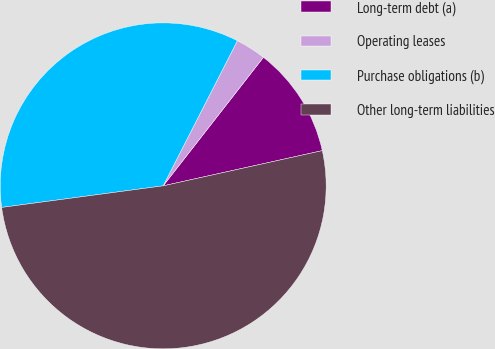Convert chart to OTSL. <chart><loc_0><loc_0><loc_500><loc_500><pie_chart><fcel>Long-term debt (a)<fcel>Operating leases<fcel>Purchase obligations (b)<fcel>Other long-term liabilities<nl><fcel>10.99%<fcel>3.02%<fcel>34.64%<fcel>51.35%<nl></chart> 